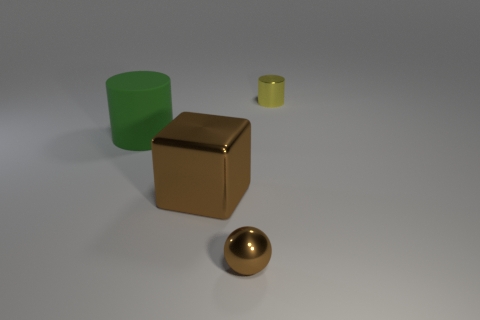Add 4 rubber things. How many objects exist? 8 Subtract 1 yellow cylinders. How many objects are left? 3 Subtract all brown cylinders. Subtract all red cubes. How many cylinders are left? 2 Subtract all small red balls. Subtract all large green things. How many objects are left? 3 Add 2 tiny yellow metal cylinders. How many tiny yellow metal cylinders are left? 3 Add 4 large yellow matte things. How many large yellow matte things exist? 4 